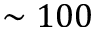<formula> <loc_0><loc_0><loc_500><loc_500>\sim 1 0 0</formula> 